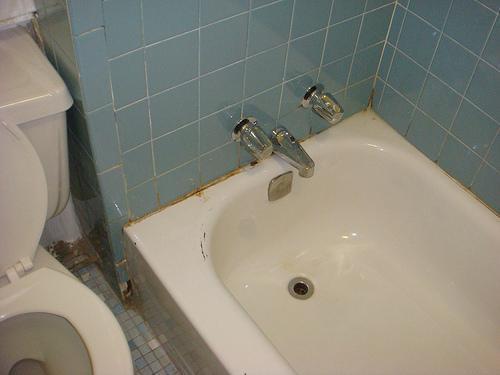How many knobs are there?
Give a very brief answer. 2. How many white fixtures are there?
Give a very brief answer. 2. 